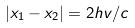Convert formula to latex. <formula><loc_0><loc_0><loc_500><loc_500>| x _ { 1 } - x _ { 2 } | = 2 h v / c</formula> 